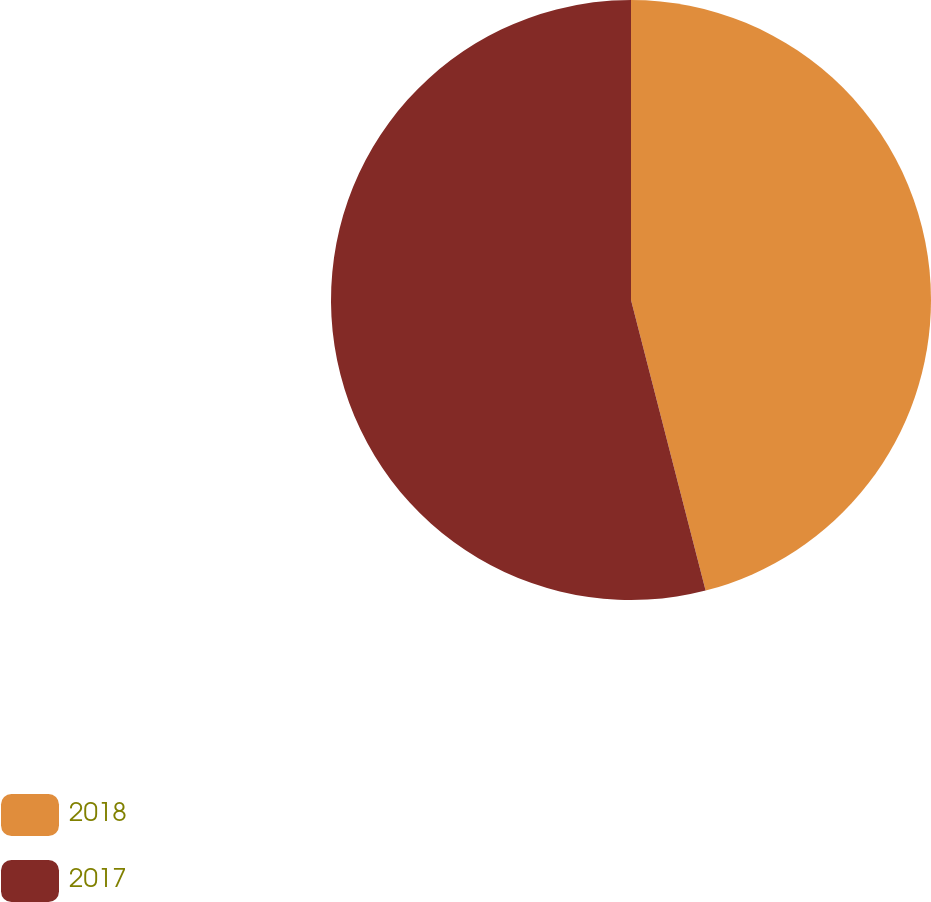Convert chart. <chart><loc_0><loc_0><loc_500><loc_500><pie_chart><fcel>2018<fcel>2017<nl><fcel>46.0%<fcel>54.0%<nl></chart> 